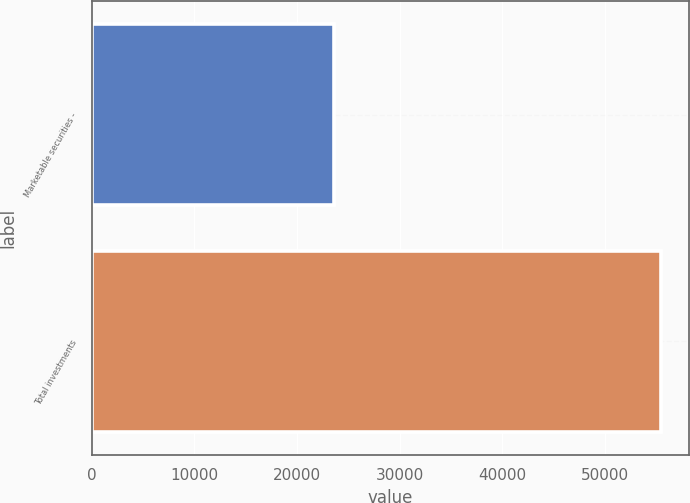Convert chart to OTSL. <chart><loc_0><loc_0><loc_500><loc_500><bar_chart><fcel>Marketable securities -<fcel>Total investments<nl><fcel>23655<fcel>55449<nl></chart> 